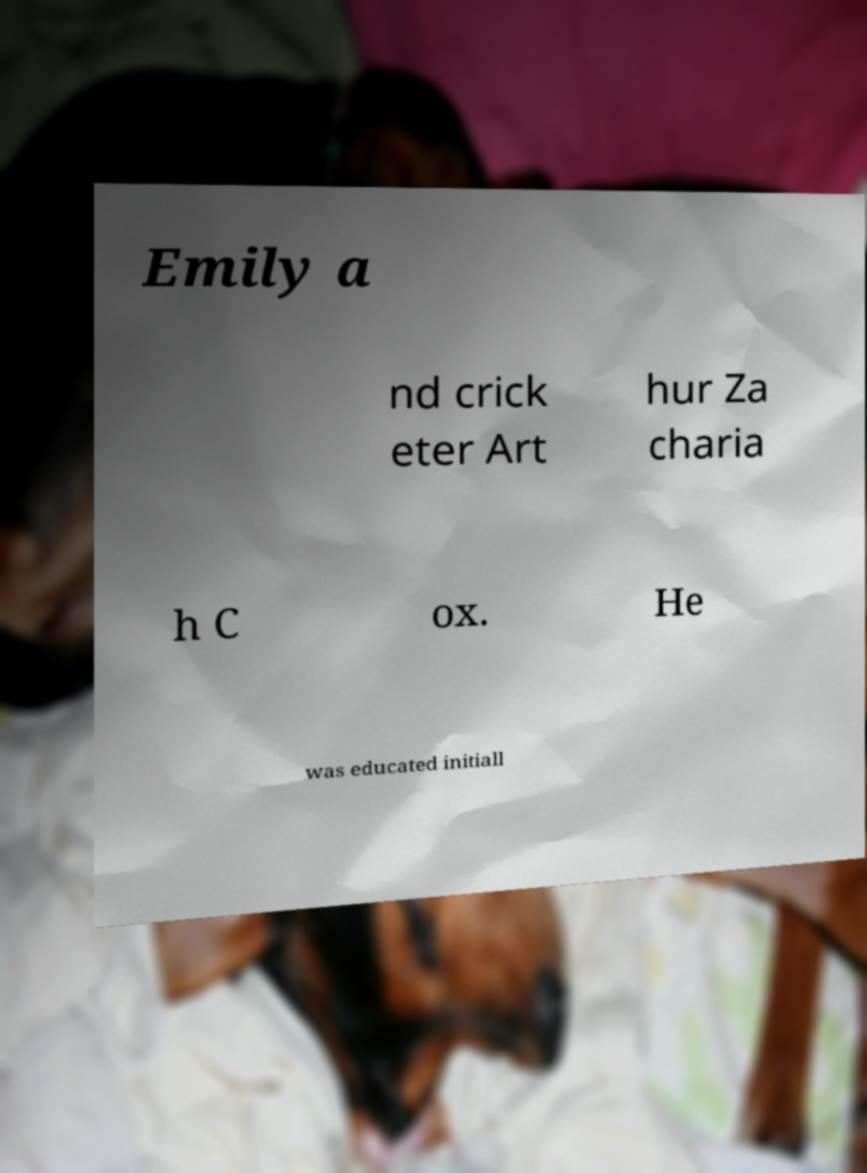Could you extract and type out the text from this image? Emily a nd crick eter Art hur Za charia h C ox. He was educated initiall 